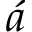Convert formula to latex. <formula><loc_0><loc_0><loc_500><loc_500>\acute { a }</formula> 